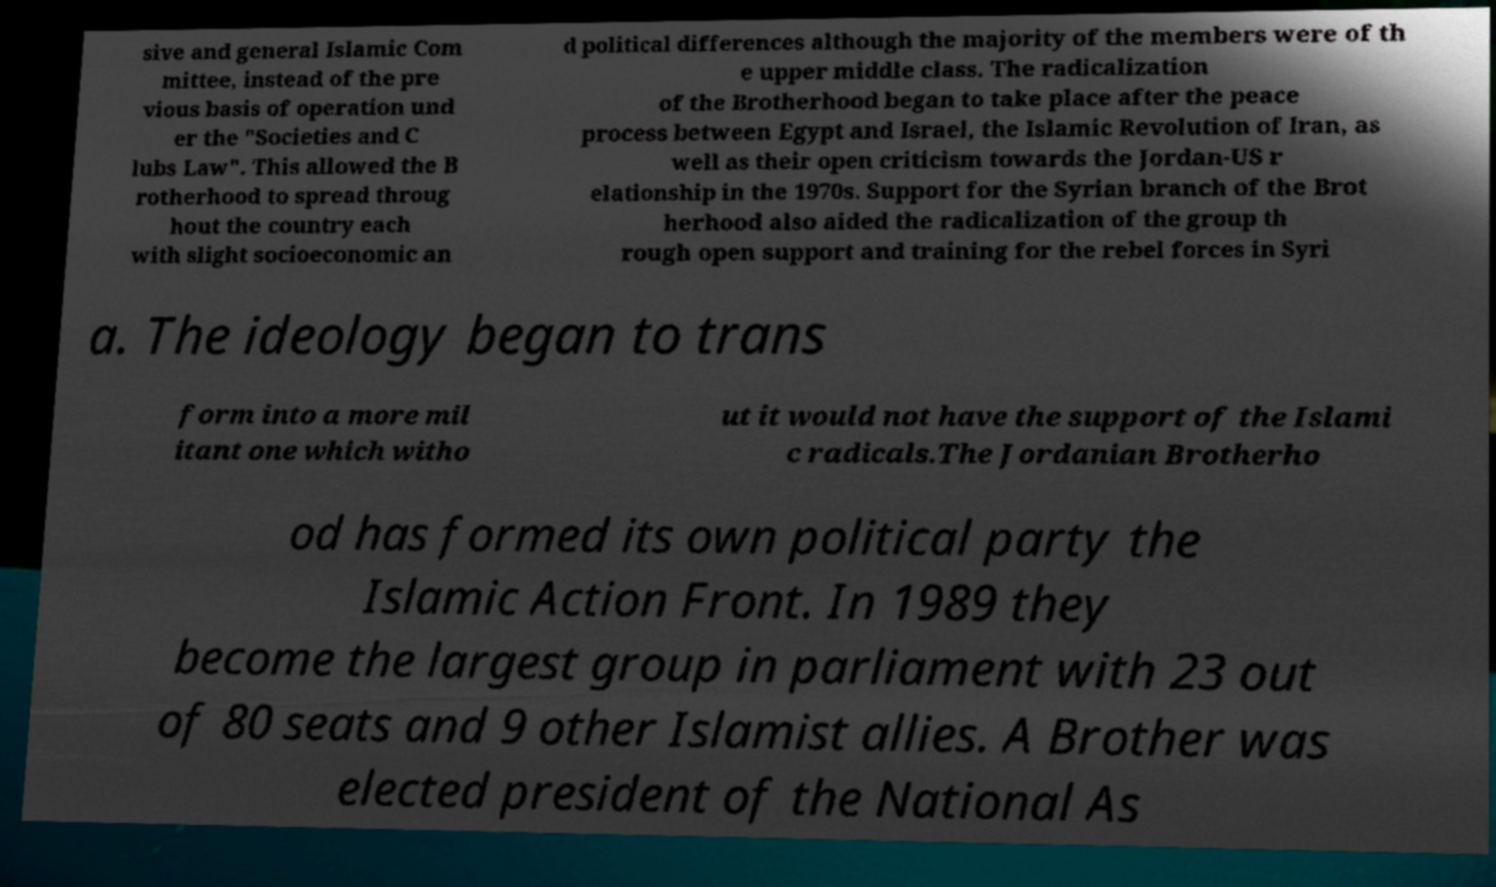There's text embedded in this image that I need extracted. Can you transcribe it verbatim? sive and general Islamic Com mittee, instead of the pre vious basis of operation und er the "Societies and C lubs Law". This allowed the B rotherhood to spread throug hout the country each with slight socioeconomic an d political differences although the majority of the members were of th e upper middle class. The radicalization of the Brotherhood began to take place after the peace process between Egypt and Israel, the Islamic Revolution of Iran, as well as their open criticism towards the Jordan-US r elationship in the 1970s. Support for the Syrian branch of the Brot herhood also aided the radicalization of the group th rough open support and training for the rebel forces in Syri a. The ideology began to trans form into a more mil itant one which witho ut it would not have the support of the Islami c radicals.The Jordanian Brotherho od has formed its own political party the Islamic Action Front. In 1989 they become the largest group in parliament with 23 out of 80 seats and 9 other Islamist allies. A Brother was elected president of the National As 